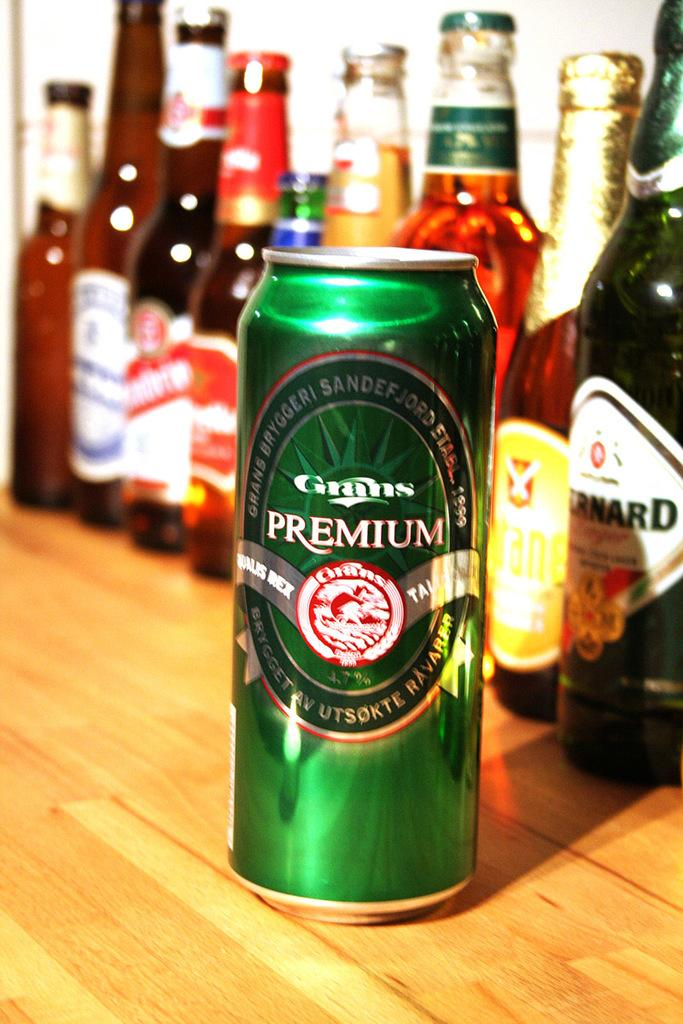<image>
Offer a succinct explanation of the picture presented. A green can has the word premium above the logo. 